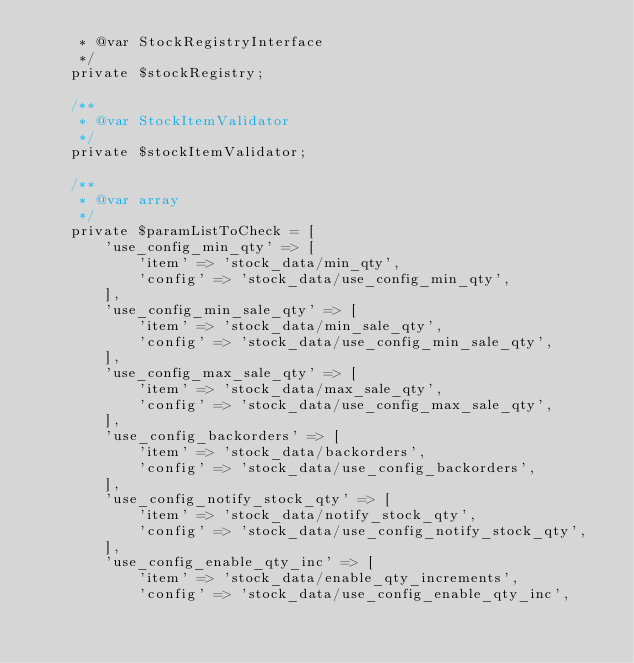Convert code to text. <code><loc_0><loc_0><loc_500><loc_500><_PHP_>     * @var StockRegistryInterface
     */
    private $stockRegistry;

    /**
     * @var StockItemValidator
     */
    private $stockItemValidator;

    /**
     * @var array
     */
    private $paramListToCheck = [
        'use_config_min_qty' => [
            'item' => 'stock_data/min_qty',
            'config' => 'stock_data/use_config_min_qty',
        ],
        'use_config_min_sale_qty' => [
            'item' => 'stock_data/min_sale_qty',
            'config' => 'stock_data/use_config_min_sale_qty',
        ],
        'use_config_max_sale_qty' => [
            'item' => 'stock_data/max_sale_qty',
            'config' => 'stock_data/use_config_max_sale_qty',
        ],
        'use_config_backorders' => [
            'item' => 'stock_data/backorders',
            'config' => 'stock_data/use_config_backorders',
        ],
        'use_config_notify_stock_qty' => [
            'item' => 'stock_data/notify_stock_qty',
            'config' => 'stock_data/use_config_notify_stock_qty',
        ],
        'use_config_enable_qty_inc' => [
            'item' => 'stock_data/enable_qty_increments',
            'config' => 'stock_data/use_config_enable_qty_inc',</code> 